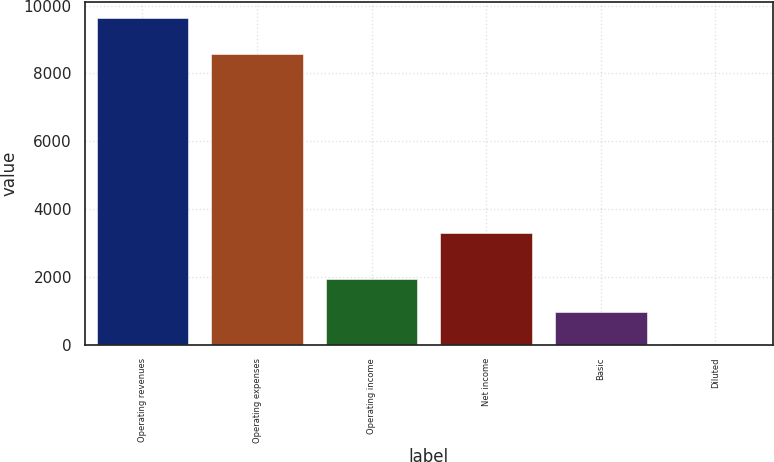Convert chart. <chart><loc_0><loc_0><loc_500><loc_500><bar_chart><fcel>Operating revenues<fcel>Operating expenses<fcel>Operating income<fcel>Net income<fcel>Basic<fcel>Diluted<nl><fcel>9630<fcel>8562<fcel>1930.07<fcel>3281<fcel>967.58<fcel>5.09<nl></chart> 